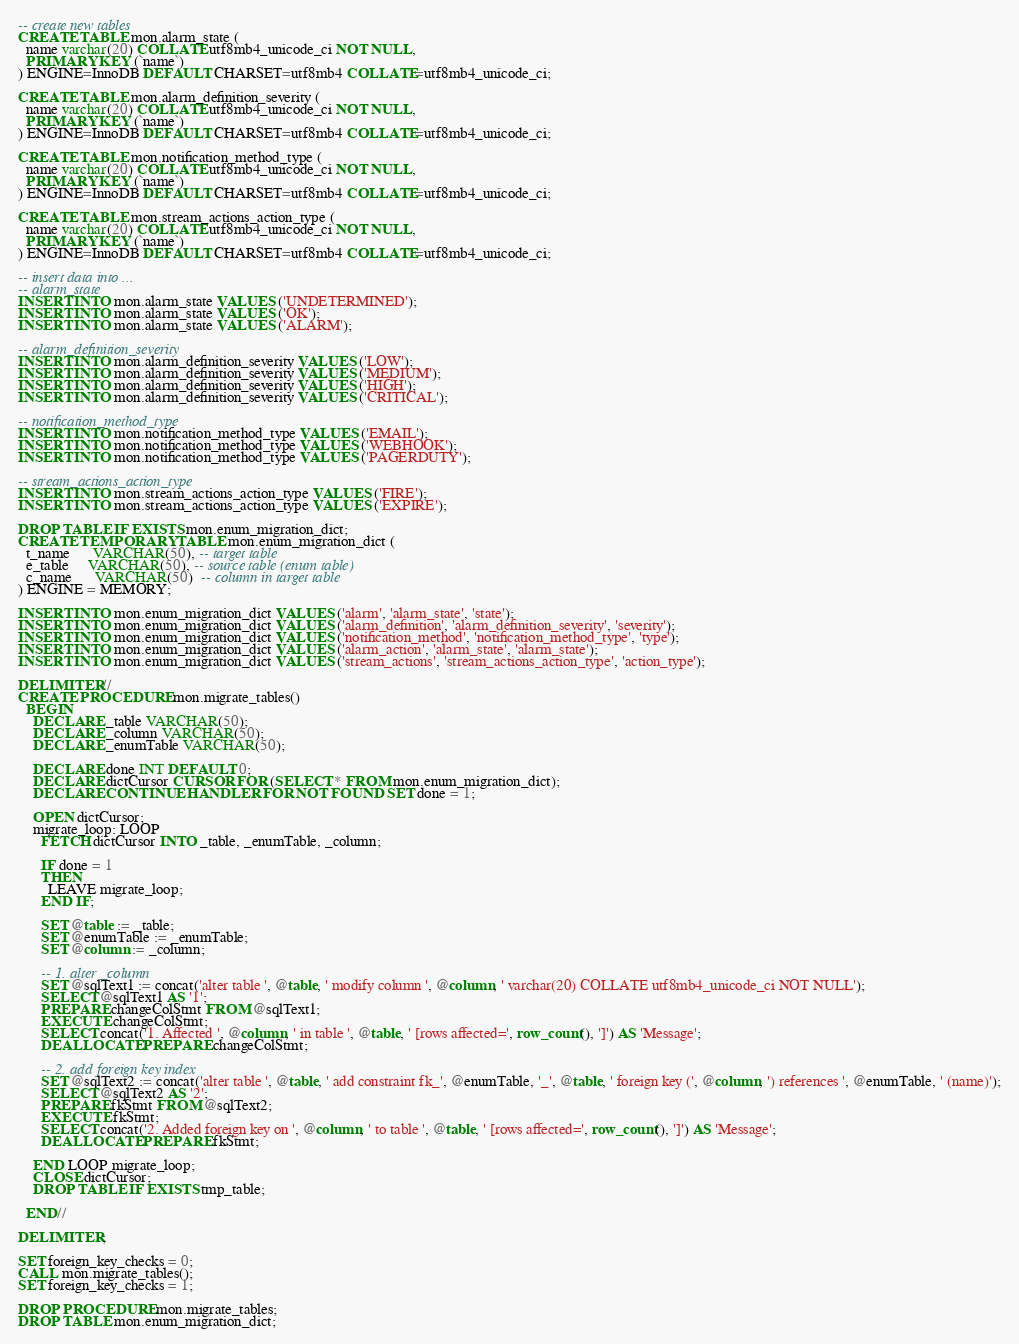Convert code to text. <code><loc_0><loc_0><loc_500><loc_500><_SQL_>-- create new tables
CREATE TABLE mon.alarm_state (
  name varchar(20) COLLATE utf8mb4_unicode_ci NOT NULL,
  PRIMARY KEY (`name`)
) ENGINE=InnoDB DEFAULT CHARSET=utf8mb4 COLLATE=utf8mb4_unicode_ci;

CREATE TABLE mon.alarm_definition_severity (
  name varchar(20) COLLATE utf8mb4_unicode_ci NOT NULL,
  PRIMARY KEY (`name`)
) ENGINE=InnoDB DEFAULT CHARSET=utf8mb4 COLLATE=utf8mb4_unicode_ci;

CREATE TABLE mon.notification_method_type (
  name varchar(20) COLLATE utf8mb4_unicode_ci NOT NULL,
  PRIMARY KEY (`name`)
) ENGINE=InnoDB DEFAULT CHARSET=utf8mb4 COLLATE=utf8mb4_unicode_ci;

CREATE TABLE mon.stream_actions_action_type (
  name varchar(20) COLLATE utf8mb4_unicode_ci NOT NULL,
  PRIMARY KEY (`name`)
) ENGINE=InnoDB DEFAULT CHARSET=utf8mb4 COLLATE=utf8mb4_unicode_ci;

-- insert data into ...
-- alarm_state
INSERT INTO mon.alarm_state VALUES ('UNDETERMINED');
INSERT INTO mon.alarm_state VALUES ('OK');
INSERT INTO mon.alarm_state VALUES ('ALARM');

-- alarm_definition_severity
INSERT INTO mon.alarm_definition_severity VALUES ('LOW');
INSERT INTO mon.alarm_definition_severity VALUES ('MEDIUM');
INSERT INTO mon.alarm_definition_severity VALUES ('HIGH');
INSERT INTO mon.alarm_definition_severity VALUES ('CRITICAL');

-- notification_method_type
INSERT INTO mon.notification_method_type VALUES ('EMAIL');
INSERT INTO mon.notification_method_type VALUES ('WEBHOOK');
INSERT INTO mon.notification_method_type VALUES ('PAGERDUTY');

-- stream_actions_action_type
INSERT INTO mon.stream_actions_action_type VALUES ('FIRE');
INSERT INTO mon.stream_actions_action_type VALUES ('EXPIRE');

DROP TABLE IF EXISTS mon.enum_migration_dict;
CREATE TEMPORARY TABLE mon.enum_migration_dict (
  t_name      VARCHAR(50), -- target table
  e_table     VARCHAR(50), -- source table (enum table)
  c_name      VARCHAR(50)  -- column in target table
) ENGINE = MEMORY;

INSERT INTO mon.enum_migration_dict VALUES ('alarm', 'alarm_state', 'state');
INSERT INTO mon.enum_migration_dict VALUES ('alarm_definition', 'alarm_definition_severity', 'severity');
INSERT INTO mon.enum_migration_dict VALUES ('notification_method', 'notification_method_type', 'type');
INSERT INTO mon.enum_migration_dict VALUES ('alarm_action', 'alarm_state', 'alarm_state');
INSERT INTO mon.enum_migration_dict VALUES ('stream_actions', 'stream_actions_action_type', 'action_type');

DELIMITER //
CREATE PROCEDURE mon.migrate_tables()
  BEGIN
    DECLARE _table VARCHAR(50);
    DECLARE _column VARCHAR(50);
    DECLARE _enumTable VARCHAR(50);

    DECLARE done INT DEFAULT 0;
    DECLARE dictCursor CURSOR FOR (SELECT * FROM mon.enum_migration_dict);
    DECLARE CONTINUE HANDLER FOR NOT FOUND SET done = 1;

    OPEN dictCursor;
    migrate_loop: LOOP
      FETCH dictCursor INTO _table, _enumTable, _column;

      IF done = 1
      THEN
        LEAVE migrate_loop;
      END IF;

      SET @table := _table;
      SET @enumTable := _enumTable;
      SET @column := _column;

      -- 1. alter _column
      SET @sqlText1 := concat('alter table ', @table, ' modify column ', @column, ' varchar(20) COLLATE utf8mb4_unicode_ci NOT NULL');
      SELECT @sqlText1 AS '1';
      PREPARE changeColStmt FROM @sqlText1;
      EXECUTE changeColStmt;
      SELECT concat('1. Affected ', @column, ' in table ', @table, ' [rows affected=', row_count(), ']') AS 'Message';
      DEALLOCATE PREPARE changeColStmt;

      -- 2. add foreign key index
      SET @sqlText2 := concat('alter table ', @table, ' add constraint fk_', @enumTable, '_', @table, ' foreign key (', @column, ') references ', @enumTable, ' (name)');
      SELECT @sqlText2 AS '2';
      PREPARE fkStmt FROM @sqlText2;
      EXECUTE fkStmt;
      SELECT concat('2. Added foreign key on ', @column, ' to table ', @table, ' [rows affected=', row_count(), ']') AS 'Message';
      DEALLOCATE PREPARE fkStmt;

    END LOOP migrate_loop;
    CLOSE dictCursor;
    DROP TABLE IF EXISTS tmp_table;

  END//

DELIMITER ;

SET foreign_key_checks = 0;
CALL mon.migrate_tables();
SET foreign_key_checks = 1;

DROP PROCEDURE mon.migrate_tables;
DROP TABLE mon.enum_migration_dict;
</code> 